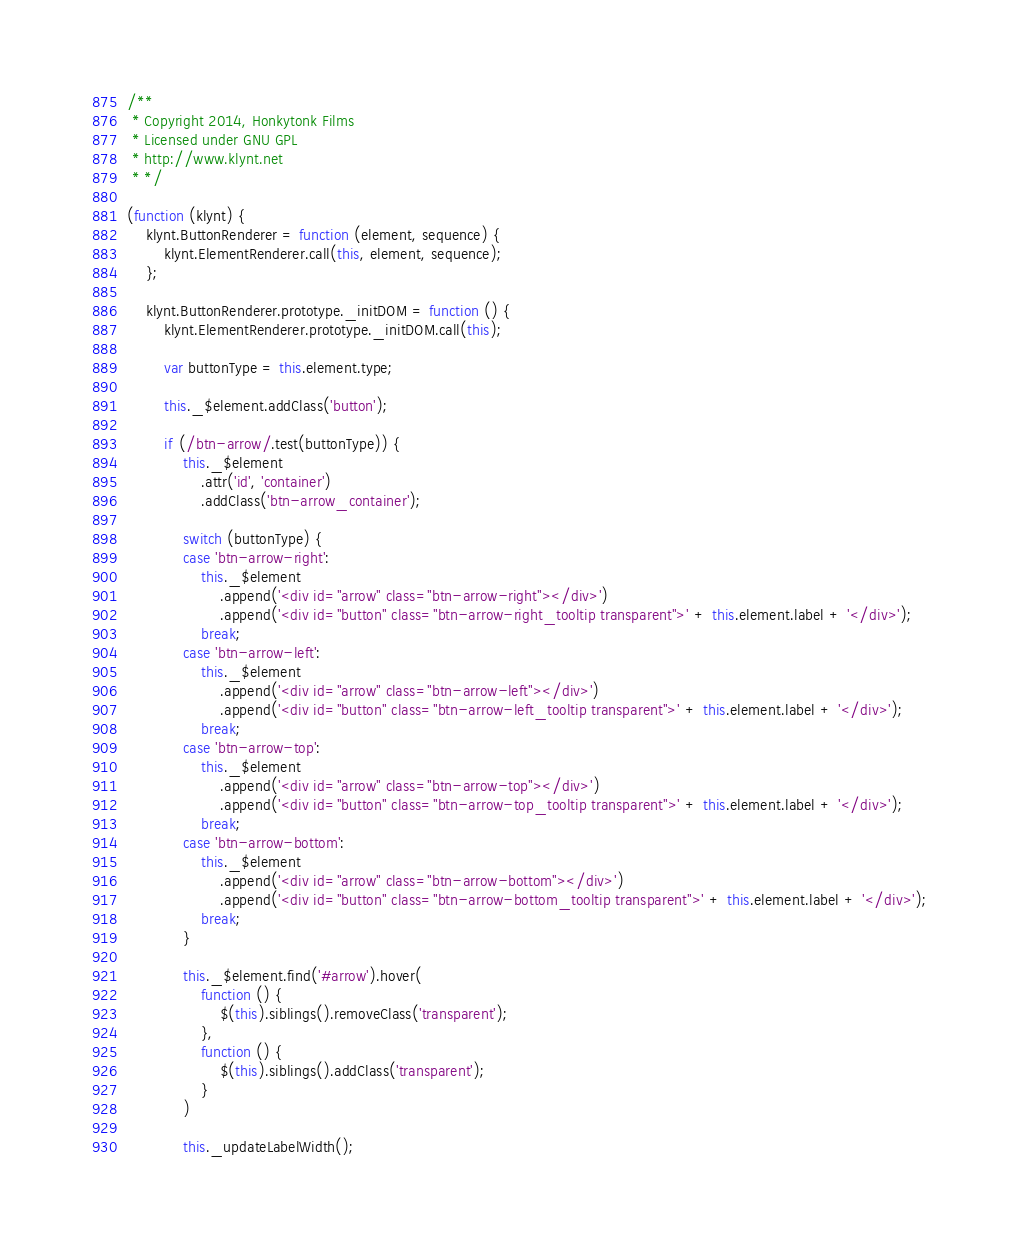Convert code to text. <code><loc_0><loc_0><loc_500><loc_500><_JavaScript_>/**
 * Copyright 2014, Honkytonk Films
 * Licensed under GNU GPL
 * http://www.klynt.net
 * */

(function (klynt) {
    klynt.ButtonRenderer = function (element, sequence) {
        klynt.ElementRenderer.call(this, element, sequence);
    };

    klynt.ButtonRenderer.prototype._initDOM = function () {
        klynt.ElementRenderer.prototype._initDOM.call(this);

        var buttonType = this.element.type;

        this._$element.addClass('button');

        if (/btn-arrow/.test(buttonType)) {
            this._$element
                .attr('id', 'container')
                .addClass('btn-arrow_container');

            switch (buttonType) {
            case 'btn-arrow-right':
                this._$element
                    .append('<div id="arrow" class="btn-arrow-right"></div>')
                    .append('<div id="button" class="btn-arrow-right_tooltip transparent">' + this.element.label + '</div>');
                break;
            case 'btn-arrow-left':
                this._$element
                    .append('<div id="arrow" class="btn-arrow-left"></div>')
                    .append('<div id="button" class="btn-arrow-left_tooltip transparent">' + this.element.label + '</div>');
                break;
            case 'btn-arrow-top':
                this._$element
                    .append('<div id="arrow" class="btn-arrow-top"></div>')
                    .append('<div id="button" class="btn-arrow-top_tooltip transparent">' + this.element.label + '</div>');
                break;
            case 'btn-arrow-bottom':
                this._$element
                    .append('<div id="arrow" class="btn-arrow-bottom"></div>')
                    .append('<div id="button" class="btn-arrow-bottom_tooltip transparent">' + this.element.label + '</div>');
                break;
            }

            this._$element.find('#arrow').hover(
                function () {
                    $(this).siblings().removeClass('transparent');
                },
                function () {
                    $(this).siblings().addClass('transparent');
                }
            )

            this._updateLabelWidth();</code> 